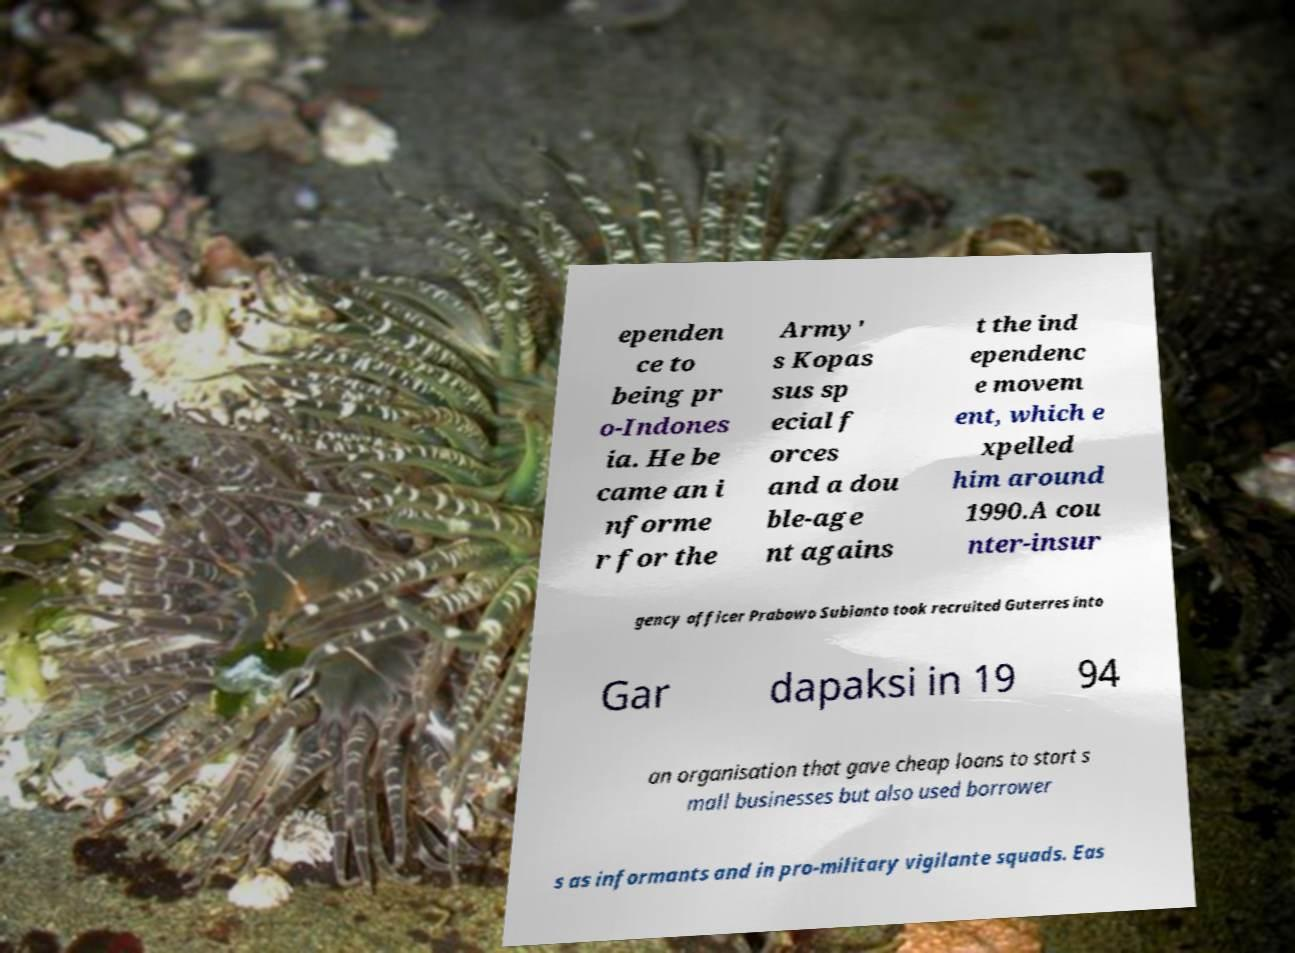What messages or text are displayed in this image? I need them in a readable, typed format. ependen ce to being pr o-Indones ia. He be came an i nforme r for the Army' s Kopas sus sp ecial f orces and a dou ble-age nt agains t the ind ependenc e movem ent, which e xpelled him around 1990.A cou nter-insur gency officer Prabowo Subianto took recruited Guterres into Gar dapaksi in 19 94 an organisation that gave cheap loans to start s mall businesses but also used borrower s as informants and in pro-military vigilante squads. Eas 